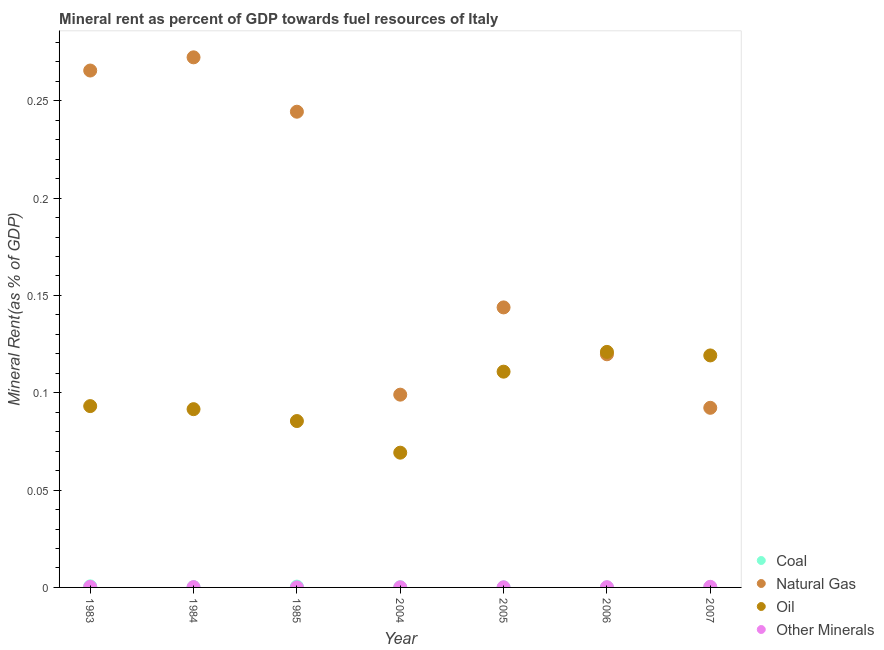Is the number of dotlines equal to the number of legend labels?
Make the answer very short. Yes. What is the natural gas rent in 2004?
Offer a terse response. 0.1. Across all years, what is the maximum natural gas rent?
Your answer should be compact. 0.27. Across all years, what is the minimum  rent of other minerals?
Offer a very short reply. 9.961583224840801e-6. In which year was the  rent of other minerals maximum?
Provide a short and direct response. 2007. What is the total  rent of other minerals in the graph?
Your answer should be very brief. 0. What is the difference between the oil rent in 2004 and that in 2005?
Ensure brevity in your answer.  -0.04. What is the difference between the  rent of other minerals in 1985 and the natural gas rent in 2004?
Offer a terse response. -0.1. What is the average  rent of other minerals per year?
Make the answer very short. 0. In the year 2007, what is the difference between the coal rent and natural gas rent?
Your answer should be compact. -0.09. In how many years, is the natural gas rent greater than 0.24000000000000002 %?
Offer a very short reply. 3. What is the ratio of the natural gas rent in 1985 to that in 2006?
Your response must be concise. 2.04. Is the oil rent in 1984 less than that in 2006?
Your response must be concise. Yes. What is the difference between the highest and the second highest coal rent?
Your response must be concise. 0. What is the difference between the highest and the lowest  rent of other minerals?
Offer a terse response. 0. Is the sum of the natural gas rent in 1983 and 2007 greater than the maximum  rent of other minerals across all years?
Offer a very short reply. Yes. Is it the case that in every year, the sum of the  rent of other minerals and coal rent is greater than the sum of natural gas rent and oil rent?
Your response must be concise. No. Is it the case that in every year, the sum of the coal rent and natural gas rent is greater than the oil rent?
Your answer should be compact. No. Does the oil rent monotonically increase over the years?
Offer a terse response. No. Is the  rent of other minerals strictly less than the natural gas rent over the years?
Your answer should be compact. Yes. How many dotlines are there?
Offer a very short reply. 4. Does the graph contain any zero values?
Make the answer very short. No. Where does the legend appear in the graph?
Your answer should be compact. Bottom right. What is the title of the graph?
Offer a very short reply. Mineral rent as percent of GDP towards fuel resources of Italy. Does "Secondary vocational" appear as one of the legend labels in the graph?
Ensure brevity in your answer.  No. What is the label or title of the Y-axis?
Ensure brevity in your answer.  Mineral Rent(as % of GDP). What is the Mineral Rent(as % of GDP) of Coal in 1983?
Keep it short and to the point. 0. What is the Mineral Rent(as % of GDP) in Natural Gas in 1983?
Keep it short and to the point. 0.27. What is the Mineral Rent(as % of GDP) of Oil in 1983?
Your answer should be very brief. 0.09. What is the Mineral Rent(as % of GDP) of Other Minerals in 1983?
Your response must be concise. 0. What is the Mineral Rent(as % of GDP) of Coal in 1984?
Keep it short and to the point. 0. What is the Mineral Rent(as % of GDP) of Natural Gas in 1984?
Make the answer very short. 0.27. What is the Mineral Rent(as % of GDP) in Oil in 1984?
Provide a succinct answer. 0.09. What is the Mineral Rent(as % of GDP) of Other Minerals in 1984?
Make the answer very short. 0. What is the Mineral Rent(as % of GDP) in Coal in 1985?
Your answer should be compact. 0. What is the Mineral Rent(as % of GDP) of Natural Gas in 1985?
Give a very brief answer. 0.24. What is the Mineral Rent(as % of GDP) in Oil in 1985?
Give a very brief answer. 0.09. What is the Mineral Rent(as % of GDP) of Other Minerals in 1985?
Your response must be concise. 9.961583224840801e-6. What is the Mineral Rent(as % of GDP) in Coal in 2004?
Your answer should be very brief. 6.69671559886923e-5. What is the Mineral Rent(as % of GDP) of Natural Gas in 2004?
Keep it short and to the point. 0.1. What is the Mineral Rent(as % of GDP) of Oil in 2004?
Make the answer very short. 0.07. What is the Mineral Rent(as % of GDP) of Other Minerals in 2004?
Your answer should be very brief. 5.04562722027911e-5. What is the Mineral Rent(as % of GDP) of Coal in 2005?
Offer a very short reply. 1.52938665315344e-5. What is the Mineral Rent(as % of GDP) in Natural Gas in 2005?
Provide a short and direct response. 0.14. What is the Mineral Rent(as % of GDP) in Oil in 2005?
Give a very brief answer. 0.11. What is the Mineral Rent(as % of GDP) in Other Minerals in 2005?
Keep it short and to the point. 5.19978483060913e-5. What is the Mineral Rent(as % of GDP) of Coal in 2006?
Keep it short and to the point. 5.16849671469394e-6. What is the Mineral Rent(as % of GDP) of Natural Gas in 2006?
Provide a succinct answer. 0.12. What is the Mineral Rent(as % of GDP) in Oil in 2006?
Your answer should be compact. 0.12. What is the Mineral Rent(as % of GDP) in Other Minerals in 2006?
Your answer should be very brief. 0. What is the Mineral Rent(as % of GDP) of Coal in 2007?
Your answer should be very brief. 0. What is the Mineral Rent(as % of GDP) in Natural Gas in 2007?
Your response must be concise. 0.09. What is the Mineral Rent(as % of GDP) in Oil in 2007?
Make the answer very short. 0.12. What is the Mineral Rent(as % of GDP) in Other Minerals in 2007?
Keep it short and to the point. 0. Across all years, what is the maximum Mineral Rent(as % of GDP) in Coal?
Your answer should be compact. 0. Across all years, what is the maximum Mineral Rent(as % of GDP) of Natural Gas?
Ensure brevity in your answer.  0.27. Across all years, what is the maximum Mineral Rent(as % of GDP) of Oil?
Provide a short and direct response. 0.12. Across all years, what is the maximum Mineral Rent(as % of GDP) in Other Minerals?
Offer a very short reply. 0. Across all years, what is the minimum Mineral Rent(as % of GDP) in Coal?
Give a very brief answer. 5.16849671469394e-6. Across all years, what is the minimum Mineral Rent(as % of GDP) in Natural Gas?
Offer a terse response. 0.09. Across all years, what is the minimum Mineral Rent(as % of GDP) of Oil?
Make the answer very short. 0.07. Across all years, what is the minimum Mineral Rent(as % of GDP) in Other Minerals?
Keep it short and to the point. 9.961583224840801e-6. What is the total Mineral Rent(as % of GDP) in Coal in the graph?
Make the answer very short. 0. What is the total Mineral Rent(as % of GDP) of Natural Gas in the graph?
Your response must be concise. 1.24. What is the total Mineral Rent(as % of GDP) of Oil in the graph?
Give a very brief answer. 0.69. What is the difference between the Mineral Rent(as % of GDP) of Coal in 1983 and that in 1984?
Make the answer very short. 0. What is the difference between the Mineral Rent(as % of GDP) of Natural Gas in 1983 and that in 1984?
Ensure brevity in your answer.  -0.01. What is the difference between the Mineral Rent(as % of GDP) of Oil in 1983 and that in 1984?
Ensure brevity in your answer.  0. What is the difference between the Mineral Rent(as % of GDP) in Coal in 1983 and that in 1985?
Keep it short and to the point. 0. What is the difference between the Mineral Rent(as % of GDP) in Natural Gas in 1983 and that in 1985?
Offer a terse response. 0.02. What is the difference between the Mineral Rent(as % of GDP) in Oil in 1983 and that in 1985?
Give a very brief answer. 0.01. What is the difference between the Mineral Rent(as % of GDP) in Natural Gas in 1983 and that in 2004?
Offer a very short reply. 0.17. What is the difference between the Mineral Rent(as % of GDP) of Oil in 1983 and that in 2004?
Make the answer very short. 0.02. What is the difference between the Mineral Rent(as % of GDP) of Coal in 1983 and that in 2005?
Offer a very short reply. 0. What is the difference between the Mineral Rent(as % of GDP) in Natural Gas in 1983 and that in 2005?
Give a very brief answer. 0.12. What is the difference between the Mineral Rent(as % of GDP) of Oil in 1983 and that in 2005?
Your response must be concise. -0.02. What is the difference between the Mineral Rent(as % of GDP) of Other Minerals in 1983 and that in 2005?
Ensure brevity in your answer.  0. What is the difference between the Mineral Rent(as % of GDP) of Natural Gas in 1983 and that in 2006?
Keep it short and to the point. 0.15. What is the difference between the Mineral Rent(as % of GDP) of Oil in 1983 and that in 2006?
Offer a very short reply. -0.03. What is the difference between the Mineral Rent(as % of GDP) in Coal in 1983 and that in 2007?
Your response must be concise. 0. What is the difference between the Mineral Rent(as % of GDP) in Natural Gas in 1983 and that in 2007?
Make the answer very short. 0.17. What is the difference between the Mineral Rent(as % of GDP) in Oil in 1983 and that in 2007?
Make the answer very short. -0.03. What is the difference between the Mineral Rent(as % of GDP) of Coal in 1984 and that in 1985?
Make the answer very short. -0. What is the difference between the Mineral Rent(as % of GDP) in Natural Gas in 1984 and that in 1985?
Make the answer very short. 0.03. What is the difference between the Mineral Rent(as % of GDP) in Oil in 1984 and that in 1985?
Ensure brevity in your answer.  0.01. What is the difference between the Mineral Rent(as % of GDP) of Other Minerals in 1984 and that in 1985?
Offer a very short reply. 0. What is the difference between the Mineral Rent(as % of GDP) in Coal in 1984 and that in 2004?
Ensure brevity in your answer.  0. What is the difference between the Mineral Rent(as % of GDP) in Natural Gas in 1984 and that in 2004?
Your answer should be compact. 0.17. What is the difference between the Mineral Rent(as % of GDP) of Oil in 1984 and that in 2004?
Keep it short and to the point. 0.02. What is the difference between the Mineral Rent(as % of GDP) of Coal in 1984 and that in 2005?
Offer a very short reply. 0. What is the difference between the Mineral Rent(as % of GDP) in Natural Gas in 1984 and that in 2005?
Provide a short and direct response. 0.13. What is the difference between the Mineral Rent(as % of GDP) of Oil in 1984 and that in 2005?
Make the answer very short. -0.02. What is the difference between the Mineral Rent(as % of GDP) in Coal in 1984 and that in 2006?
Offer a very short reply. 0. What is the difference between the Mineral Rent(as % of GDP) in Natural Gas in 1984 and that in 2006?
Your response must be concise. 0.15. What is the difference between the Mineral Rent(as % of GDP) of Oil in 1984 and that in 2006?
Your answer should be compact. -0.03. What is the difference between the Mineral Rent(as % of GDP) in Natural Gas in 1984 and that in 2007?
Your answer should be compact. 0.18. What is the difference between the Mineral Rent(as % of GDP) of Oil in 1984 and that in 2007?
Provide a succinct answer. -0.03. What is the difference between the Mineral Rent(as % of GDP) in Other Minerals in 1984 and that in 2007?
Give a very brief answer. -0. What is the difference between the Mineral Rent(as % of GDP) of Coal in 1985 and that in 2004?
Offer a very short reply. 0. What is the difference between the Mineral Rent(as % of GDP) in Natural Gas in 1985 and that in 2004?
Provide a short and direct response. 0.15. What is the difference between the Mineral Rent(as % of GDP) in Oil in 1985 and that in 2004?
Your response must be concise. 0.02. What is the difference between the Mineral Rent(as % of GDP) of Other Minerals in 1985 and that in 2004?
Make the answer very short. -0. What is the difference between the Mineral Rent(as % of GDP) of Natural Gas in 1985 and that in 2005?
Offer a terse response. 0.1. What is the difference between the Mineral Rent(as % of GDP) of Oil in 1985 and that in 2005?
Offer a very short reply. -0.03. What is the difference between the Mineral Rent(as % of GDP) of Natural Gas in 1985 and that in 2006?
Offer a very short reply. 0.12. What is the difference between the Mineral Rent(as % of GDP) of Oil in 1985 and that in 2006?
Keep it short and to the point. -0.04. What is the difference between the Mineral Rent(as % of GDP) of Other Minerals in 1985 and that in 2006?
Offer a very short reply. -0. What is the difference between the Mineral Rent(as % of GDP) in Natural Gas in 1985 and that in 2007?
Your answer should be compact. 0.15. What is the difference between the Mineral Rent(as % of GDP) of Oil in 1985 and that in 2007?
Your answer should be compact. -0.03. What is the difference between the Mineral Rent(as % of GDP) of Other Minerals in 1985 and that in 2007?
Offer a very short reply. -0. What is the difference between the Mineral Rent(as % of GDP) in Coal in 2004 and that in 2005?
Your answer should be compact. 0. What is the difference between the Mineral Rent(as % of GDP) in Natural Gas in 2004 and that in 2005?
Offer a very short reply. -0.04. What is the difference between the Mineral Rent(as % of GDP) of Oil in 2004 and that in 2005?
Provide a succinct answer. -0.04. What is the difference between the Mineral Rent(as % of GDP) in Coal in 2004 and that in 2006?
Offer a very short reply. 0. What is the difference between the Mineral Rent(as % of GDP) of Natural Gas in 2004 and that in 2006?
Keep it short and to the point. -0.02. What is the difference between the Mineral Rent(as % of GDP) of Oil in 2004 and that in 2006?
Your answer should be very brief. -0.05. What is the difference between the Mineral Rent(as % of GDP) in Other Minerals in 2004 and that in 2006?
Your answer should be compact. -0. What is the difference between the Mineral Rent(as % of GDP) of Natural Gas in 2004 and that in 2007?
Give a very brief answer. 0.01. What is the difference between the Mineral Rent(as % of GDP) of Other Minerals in 2004 and that in 2007?
Ensure brevity in your answer.  -0. What is the difference between the Mineral Rent(as % of GDP) in Coal in 2005 and that in 2006?
Make the answer very short. 0. What is the difference between the Mineral Rent(as % of GDP) in Natural Gas in 2005 and that in 2006?
Provide a short and direct response. 0.02. What is the difference between the Mineral Rent(as % of GDP) in Oil in 2005 and that in 2006?
Give a very brief answer. -0.01. What is the difference between the Mineral Rent(as % of GDP) in Other Minerals in 2005 and that in 2006?
Make the answer very short. -0. What is the difference between the Mineral Rent(as % of GDP) in Coal in 2005 and that in 2007?
Provide a short and direct response. -0. What is the difference between the Mineral Rent(as % of GDP) of Natural Gas in 2005 and that in 2007?
Your answer should be very brief. 0.05. What is the difference between the Mineral Rent(as % of GDP) in Oil in 2005 and that in 2007?
Provide a succinct answer. -0.01. What is the difference between the Mineral Rent(as % of GDP) of Other Minerals in 2005 and that in 2007?
Provide a short and direct response. -0. What is the difference between the Mineral Rent(as % of GDP) in Coal in 2006 and that in 2007?
Provide a succinct answer. -0. What is the difference between the Mineral Rent(as % of GDP) in Natural Gas in 2006 and that in 2007?
Keep it short and to the point. 0.03. What is the difference between the Mineral Rent(as % of GDP) of Oil in 2006 and that in 2007?
Offer a terse response. 0. What is the difference between the Mineral Rent(as % of GDP) in Other Minerals in 2006 and that in 2007?
Ensure brevity in your answer.  -0. What is the difference between the Mineral Rent(as % of GDP) in Coal in 1983 and the Mineral Rent(as % of GDP) in Natural Gas in 1984?
Make the answer very short. -0.27. What is the difference between the Mineral Rent(as % of GDP) in Coal in 1983 and the Mineral Rent(as % of GDP) in Oil in 1984?
Offer a terse response. -0.09. What is the difference between the Mineral Rent(as % of GDP) of Natural Gas in 1983 and the Mineral Rent(as % of GDP) of Oil in 1984?
Make the answer very short. 0.17. What is the difference between the Mineral Rent(as % of GDP) in Natural Gas in 1983 and the Mineral Rent(as % of GDP) in Other Minerals in 1984?
Keep it short and to the point. 0.27. What is the difference between the Mineral Rent(as % of GDP) of Oil in 1983 and the Mineral Rent(as % of GDP) of Other Minerals in 1984?
Your answer should be very brief. 0.09. What is the difference between the Mineral Rent(as % of GDP) of Coal in 1983 and the Mineral Rent(as % of GDP) of Natural Gas in 1985?
Your response must be concise. -0.24. What is the difference between the Mineral Rent(as % of GDP) of Coal in 1983 and the Mineral Rent(as % of GDP) of Oil in 1985?
Provide a succinct answer. -0.08. What is the difference between the Mineral Rent(as % of GDP) of Natural Gas in 1983 and the Mineral Rent(as % of GDP) of Oil in 1985?
Keep it short and to the point. 0.18. What is the difference between the Mineral Rent(as % of GDP) in Natural Gas in 1983 and the Mineral Rent(as % of GDP) in Other Minerals in 1985?
Provide a short and direct response. 0.27. What is the difference between the Mineral Rent(as % of GDP) of Oil in 1983 and the Mineral Rent(as % of GDP) of Other Minerals in 1985?
Your answer should be compact. 0.09. What is the difference between the Mineral Rent(as % of GDP) of Coal in 1983 and the Mineral Rent(as % of GDP) of Natural Gas in 2004?
Your answer should be very brief. -0.1. What is the difference between the Mineral Rent(as % of GDP) of Coal in 1983 and the Mineral Rent(as % of GDP) of Oil in 2004?
Make the answer very short. -0.07. What is the difference between the Mineral Rent(as % of GDP) of Coal in 1983 and the Mineral Rent(as % of GDP) of Other Minerals in 2004?
Give a very brief answer. 0. What is the difference between the Mineral Rent(as % of GDP) in Natural Gas in 1983 and the Mineral Rent(as % of GDP) in Oil in 2004?
Offer a terse response. 0.2. What is the difference between the Mineral Rent(as % of GDP) of Natural Gas in 1983 and the Mineral Rent(as % of GDP) of Other Minerals in 2004?
Keep it short and to the point. 0.27. What is the difference between the Mineral Rent(as % of GDP) in Oil in 1983 and the Mineral Rent(as % of GDP) in Other Minerals in 2004?
Your answer should be compact. 0.09. What is the difference between the Mineral Rent(as % of GDP) of Coal in 1983 and the Mineral Rent(as % of GDP) of Natural Gas in 2005?
Ensure brevity in your answer.  -0.14. What is the difference between the Mineral Rent(as % of GDP) in Coal in 1983 and the Mineral Rent(as % of GDP) in Oil in 2005?
Give a very brief answer. -0.11. What is the difference between the Mineral Rent(as % of GDP) of Coal in 1983 and the Mineral Rent(as % of GDP) of Other Minerals in 2005?
Ensure brevity in your answer.  0. What is the difference between the Mineral Rent(as % of GDP) of Natural Gas in 1983 and the Mineral Rent(as % of GDP) of Oil in 2005?
Offer a terse response. 0.15. What is the difference between the Mineral Rent(as % of GDP) in Natural Gas in 1983 and the Mineral Rent(as % of GDP) in Other Minerals in 2005?
Your answer should be compact. 0.27. What is the difference between the Mineral Rent(as % of GDP) of Oil in 1983 and the Mineral Rent(as % of GDP) of Other Minerals in 2005?
Your answer should be very brief. 0.09. What is the difference between the Mineral Rent(as % of GDP) in Coal in 1983 and the Mineral Rent(as % of GDP) in Natural Gas in 2006?
Your response must be concise. -0.12. What is the difference between the Mineral Rent(as % of GDP) in Coal in 1983 and the Mineral Rent(as % of GDP) in Oil in 2006?
Offer a very short reply. -0.12. What is the difference between the Mineral Rent(as % of GDP) in Coal in 1983 and the Mineral Rent(as % of GDP) in Other Minerals in 2006?
Offer a very short reply. 0. What is the difference between the Mineral Rent(as % of GDP) of Natural Gas in 1983 and the Mineral Rent(as % of GDP) of Oil in 2006?
Ensure brevity in your answer.  0.14. What is the difference between the Mineral Rent(as % of GDP) in Natural Gas in 1983 and the Mineral Rent(as % of GDP) in Other Minerals in 2006?
Ensure brevity in your answer.  0.27. What is the difference between the Mineral Rent(as % of GDP) in Oil in 1983 and the Mineral Rent(as % of GDP) in Other Minerals in 2006?
Ensure brevity in your answer.  0.09. What is the difference between the Mineral Rent(as % of GDP) of Coal in 1983 and the Mineral Rent(as % of GDP) of Natural Gas in 2007?
Ensure brevity in your answer.  -0.09. What is the difference between the Mineral Rent(as % of GDP) in Coal in 1983 and the Mineral Rent(as % of GDP) in Oil in 2007?
Your answer should be compact. -0.12. What is the difference between the Mineral Rent(as % of GDP) in Natural Gas in 1983 and the Mineral Rent(as % of GDP) in Oil in 2007?
Your answer should be very brief. 0.15. What is the difference between the Mineral Rent(as % of GDP) in Natural Gas in 1983 and the Mineral Rent(as % of GDP) in Other Minerals in 2007?
Provide a short and direct response. 0.27. What is the difference between the Mineral Rent(as % of GDP) of Oil in 1983 and the Mineral Rent(as % of GDP) of Other Minerals in 2007?
Your response must be concise. 0.09. What is the difference between the Mineral Rent(as % of GDP) in Coal in 1984 and the Mineral Rent(as % of GDP) in Natural Gas in 1985?
Keep it short and to the point. -0.24. What is the difference between the Mineral Rent(as % of GDP) of Coal in 1984 and the Mineral Rent(as % of GDP) of Oil in 1985?
Ensure brevity in your answer.  -0.09. What is the difference between the Mineral Rent(as % of GDP) of Coal in 1984 and the Mineral Rent(as % of GDP) of Other Minerals in 1985?
Your answer should be compact. 0. What is the difference between the Mineral Rent(as % of GDP) in Natural Gas in 1984 and the Mineral Rent(as % of GDP) in Oil in 1985?
Provide a succinct answer. 0.19. What is the difference between the Mineral Rent(as % of GDP) of Natural Gas in 1984 and the Mineral Rent(as % of GDP) of Other Minerals in 1985?
Your answer should be compact. 0.27. What is the difference between the Mineral Rent(as % of GDP) in Oil in 1984 and the Mineral Rent(as % of GDP) in Other Minerals in 1985?
Offer a very short reply. 0.09. What is the difference between the Mineral Rent(as % of GDP) in Coal in 1984 and the Mineral Rent(as % of GDP) in Natural Gas in 2004?
Provide a succinct answer. -0.1. What is the difference between the Mineral Rent(as % of GDP) in Coal in 1984 and the Mineral Rent(as % of GDP) in Oil in 2004?
Offer a terse response. -0.07. What is the difference between the Mineral Rent(as % of GDP) in Coal in 1984 and the Mineral Rent(as % of GDP) in Other Minerals in 2004?
Ensure brevity in your answer.  0. What is the difference between the Mineral Rent(as % of GDP) in Natural Gas in 1984 and the Mineral Rent(as % of GDP) in Oil in 2004?
Keep it short and to the point. 0.2. What is the difference between the Mineral Rent(as % of GDP) in Natural Gas in 1984 and the Mineral Rent(as % of GDP) in Other Minerals in 2004?
Offer a terse response. 0.27. What is the difference between the Mineral Rent(as % of GDP) of Oil in 1984 and the Mineral Rent(as % of GDP) of Other Minerals in 2004?
Provide a short and direct response. 0.09. What is the difference between the Mineral Rent(as % of GDP) in Coal in 1984 and the Mineral Rent(as % of GDP) in Natural Gas in 2005?
Your answer should be compact. -0.14. What is the difference between the Mineral Rent(as % of GDP) in Coal in 1984 and the Mineral Rent(as % of GDP) in Oil in 2005?
Offer a terse response. -0.11. What is the difference between the Mineral Rent(as % of GDP) of Natural Gas in 1984 and the Mineral Rent(as % of GDP) of Oil in 2005?
Your answer should be very brief. 0.16. What is the difference between the Mineral Rent(as % of GDP) of Natural Gas in 1984 and the Mineral Rent(as % of GDP) of Other Minerals in 2005?
Offer a terse response. 0.27. What is the difference between the Mineral Rent(as % of GDP) of Oil in 1984 and the Mineral Rent(as % of GDP) of Other Minerals in 2005?
Make the answer very short. 0.09. What is the difference between the Mineral Rent(as % of GDP) of Coal in 1984 and the Mineral Rent(as % of GDP) of Natural Gas in 2006?
Your answer should be very brief. -0.12. What is the difference between the Mineral Rent(as % of GDP) in Coal in 1984 and the Mineral Rent(as % of GDP) in Oil in 2006?
Your answer should be compact. -0.12. What is the difference between the Mineral Rent(as % of GDP) of Coal in 1984 and the Mineral Rent(as % of GDP) of Other Minerals in 2006?
Provide a succinct answer. -0. What is the difference between the Mineral Rent(as % of GDP) of Natural Gas in 1984 and the Mineral Rent(as % of GDP) of Oil in 2006?
Keep it short and to the point. 0.15. What is the difference between the Mineral Rent(as % of GDP) in Natural Gas in 1984 and the Mineral Rent(as % of GDP) in Other Minerals in 2006?
Offer a very short reply. 0.27. What is the difference between the Mineral Rent(as % of GDP) of Oil in 1984 and the Mineral Rent(as % of GDP) of Other Minerals in 2006?
Provide a succinct answer. 0.09. What is the difference between the Mineral Rent(as % of GDP) of Coal in 1984 and the Mineral Rent(as % of GDP) of Natural Gas in 2007?
Keep it short and to the point. -0.09. What is the difference between the Mineral Rent(as % of GDP) of Coal in 1984 and the Mineral Rent(as % of GDP) of Oil in 2007?
Provide a succinct answer. -0.12. What is the difference between the Mineral Rent(as % of GDP) of Coal in 1984 and the Mineral Rent(as % of GDP) of Other Minerals in 2007?
Your response must be concise. -0. What is the difference between the Mineral Rent(as % of GDP) of Natural Gas in 1984 and the Mineral Rent(as % of GDP) of Oil in 2007?
Offer a terse response. 0.15. What is the difference between the Mineral Rent(as % of GDP) in Natural Gas in 1984 and the Mineral Rent(as % of GDP) in Other Minerals in 2007?
Your answer should be compact. 0.27. What is the difference between the Mineral Rent(as % of GDP) of Oil in 1984 and the Mineral Rent(as % of GDP) of Other Minerals in 2007?
Keep it short and to the point. 0.09. What is the difference between the Mineral Rent(as % of GDP) in Coal in 1985 and the Mineral Rent(as % of GDP) in Natural Gas in 2004?
Your answer should be very brief. -0.1. What is the difference between the Mineral Rent(as % of GDP) in Coal in 1985 and the Mineral Rent(as % of GDP) in Oil in 2004?
Make the answer very short. -0.07. What is the difference between the Mineral Rent(as % of GDP) in Natural Gas in 1985 and the Mineral Rent(as % of GDP) in Oil in 2004?
Give a very brief answer. 0.18. What is the difference between the Mineral Rent(as % of GDP) in Natural Gas in 1985 and the Mineral Rent(as % of GDP) in Other Minerals in 2004?
Provide a succinct answer. 0.24. What is the difference between the Mineral Rent(as % of GDP) of Oil in 1985 and the Mineral Rent(as % of GDP) of Other Minerals in 2004?
Offer a terse response. 0.09. What is the difference between the Mineral Rent(as % of GDP) in Coal in 1985 and the Mineral Rent(as % of GDP) in Natural Gas in 2005?
Provide a short and direct response. -0.14. What is the difference between the Mineral Rent(as % of GDP) in Coal in 1985 and the Mineral Rent(as % of GDP) in Oil in 2005?
Make the answer very short. -0.11. What is the difference between the Mineral Rent(as % of GDP) of Natural Gas in 1985 and the Mineral Rent(as % of GDP) of Oil in 2005?
Ensure brevity in your answer.  0.13. What is the difference between the Mineral Rent(as % of GDP) in Natural Gas in 1985 and the Mineral Rent(as % of GDP) in Other Minerals in 2005?
Offer a very short reply. 0.24. What is the difference between the Mineral Rent(as % of GDP) in Oil in 1985 and the Mineral Rent(as % of GDP) in Other Minerals in 2005?
Your answer should be very brief. 0.09. What is the difference between the Mineral Rent(as % of GDP) of Coal in 1985 and the Mineral Rent(as % of GDP) of Natural Gas in 2006?
Ensure brevity in your answer.  -0.12. What is the difference between the Mineral Rent(as % of GDP) of Coal in 1985 and the Mineral Rent(as % of GDP) of Oil in 2006?
Offer a very short reply. -0.12. What is the difference between the Mineral Rent(as % of GDP) in Coal in 1985 and the Mineral Rent(as % of GDP) in Other Minerals in 2006?
Make the answer very short. 0. What is the difference between the Mineral Rent(as % of GDP) of Natural Gas in 1985 and the Mineral Rent(as % of GDP) of Oil in 2006?
Your response must be concise. 0.12. What is the difference between the Mineral Rent(as % of GDP) in Natural Gas in 1985 and the Mineral Rent(as % of GDP) in Other Minerals in 2006?
Your response must be concise. 0.24. What is the difference between the Mineral Rent(as % of GDP) of Oil in 1985 and the Mineral Rent(as % of GDP) of Other Minerals in 2006?
Give a very brief answer. 0.09. What is the difference between the Mineral Rent(as % of GDP) of Coal in 1985 and the Mineral Rent(as % of GDP) of Natural Gas in 2007?
Give a very brief answer. -0.09. What is the difference between the Mineral Rent(as % of GDP) in Coal in 1985 and the Mineral Rent(as % of GDP) in Oil in 2007?
Offer a terse response. -0.12. What is the difference between the Mineral Rent(as % of GDP) in Natural Gas in 1985 and the Mineral Rent(as % of GDP) in Oil in 2007?
Ensure brevity in your answer.  0.13. What is the difference between the Mineral Rent(as % of GDP) of Natural Gas in 1985 and the Mineral Rent(as % of GDP) of Other Minerals in 2007?
Offer a terse response. 0.24. What is the difference between the Mineral Rent(as % of GDP) in Oil in 1985 and the Mineral Rent(as % of GDP) in Other Minerals in 2007?
Offer a terse response. 0.09. What is the difference between the Mineral Rent(as % of GDP) of Coal in 2004 and the Mineral Rent(as % of GDP) of Natural Gas in 2005?
Keep it short and to the point. -0.14. What is the difference between the Mineral Rent(as % of GDP) of Coal in 2004 and the Mineral Rent(as % of GDP) of Oil in 2005?
Ensure brevity in your answer.  -0.11. What is the difference between the Mineral Rent(as % of GDP) of Coal in 2004 and the Mineral Rent(as % of GDP) of Other Minerals in 2005?
Provide a succinct answer. 0. What is the difference between the Mineral Rent(as % of GDP) in Natural Gas in 2004 and the Mineral Rent(as % of GDP) in Oil in 2005?
Your response must be concise. -0.01. What is the difference between the Mineral Rent(as % of GDP) of Natural Gas in 2004 and the Mineral Rent(as % of GDP) of Other Minerals in 2005?
Keep it short and to the point. 0.1. What is the difference between the Mineral Rent(as % of GDP) in Oil in 2004 and the Mineral Rent(as % of GDP) in Other Minerals in 2005?
Offer a terse response. 0.07. What is the difference between the Mineral Rent(as % of GDP) of Coal in 2004 and the Mineral Rent(as % of GDP) of Natural Gas in 2006?
Provide a succinct answer. -0.12. What is the difference between the Mineral Rent(as % of GDP) in Coal in 2004 and the Mineral Rent(as % of GDP) in Oil in 2006?
Keep it short and to the point. -0.12. What is the difference between the Mineral Rent(as % of GDP) in Coal in 2004 and the Mineral Rent(as % of GDP) in Other Minerals in 2006?
Your answer should be very brief. -0. What is the difference between the Mineral Rent(as % of GDP) in Natural Gas in 2004 and the Mineral Rent(as % of GDP) in Oil in 2006?
Ensure brevity in your answer.  -0.02. What is the difference between the Mineral Rent(as % of GDP) of Natural Gas in 2004 and the Mineral Rent(as % of GDP) of Other Minerals in 2006?
Give a very brief answer. 0.1. What is the difference between the Mineral Rent(as % of GDP) in Oil in 2004 and the Mineral Rent(as % of GDP) in Other Minerals in 2006?
Provide a succinct answer. 0.07. What is the difference between the Mineral Rent(as % of GDP) of Coal in 2004 and the Mineral Rent(as % of GDP) of Natural Gas in 2007?
Offer a very short reply. -0.09. What is the difference between the Mineral Rent(as % of GDP) of Coal in 2004 and the Mineral Rent(as % of GDP) of Oil in 2007?
Your response must be concise. -0.12. What is the difference between the Mineral Rent(as % of GDP) of Coal in 2004 and the Mineral Rent(as % of GDP) of Other Minerals in 2007?
Give a very brief answer. -0. What is the difference between the Mineral Rent(as % of GDP) of Natural Gas in 2004 and the Mineral Rent(as % of GDP) of Oil in 2007?
Your answer should be compact. -0.02. What is the difference between the Mineral Rent(as % of GDP) of Natural Gas in 2004 and the Mineral Rent(as % of GDP) of Other Minerals in 2007?
Ensure brevity in your answer.  0.1. What is the difference between the Mineral Rent(as % of GDP) of Oil in 2004 and the Mineral Rent(as % of GDP) of Other Minerals in 2007?
Provide a short and direct response. 0.07. What is the difference between the Mineral Rent(as % of GDP) of Coal in 2005 and the Mineral Rent(as % of GDP) of Natural Gas in 2006?
Give a very brief answer. -0.12. What is the difference between the Mineral Rent(as % of GDP) of Coal in 2005 and the Mineral Rent(as % of GDP) of Oil in 2006?
Give a very brief answer. -0.12. What is the difference between the Mineral Rent(as % of GDP) in Coal in 2005 and the Mineral Rent(as % of GDP) in Other Minerals in 2006?
Keep it short and to the point. -0. What is the difference between the Mineral Rent(as % of GDP) in Natural Gas in 2005 and the Mineral Rent(as % of GDP) in Oil in 2006?
Ensure brevity in your answer.  0.02. What is the difference between the Mineral Rent(as % of GDP) of Natural Gas in 2005 and the Mineral Rent(as % of GDP) of Other Minerals in 2006?
Keep it short and to the point. 0.14. What is the difference between the Mineral Rent(as % of GDP) of Oil in 2005 and the Mineral Rent(as % of GDP) of Other Minerals in 2006?
Provide a succinct answer. 0.11. What is the difference between the Mineral Rent(as % of GDP) in Coal in 2005 and the Mineral Rent(as % of GDP) in Natural Gas in 2007?
Your answer should be compact. -0.09. What is the difference between the Mineral Rent(as % of GDP) in Coal in 2005 and the Mineral Rent(as % of GDP) in Oil in 2007?
Provide a short and direct response. -0.12. What is the difference between the Mineral Rent(as % of GDP) in Coal in 2005 and the Mineral Rent(as % of GDP) in Other Minerals in 2007?
Provide a succinct answer. -0. What is the difference between the Mineral Rent(as % of GDP) of Natural Gas in 2005 and the Mineral Rent(as % of GDP) of Oil in 2007?
Provide a short and direct response. 0.02. What is the difference between the Mineral Rent(as % of GDP) of Natural Gas in 2005 and the Mineral Rent(as % of GDP) of Other Minerals in 2007?
Your response must be concise. 0.14. What is the difference between the Mineral Rent(as % of GDP) of Oil in 2005 and the Mineral Rent(as % of GDP) of Other Minerals in 2007?
Offer a very short reply. 0.11. What is the difference between the Mineral Rent(as % of GDP) of Coal in 2006 and the Mineral Rent(as % of GDP) of Natural Gas in 2007?
Your answer should be very brief. -0.09. What is the difference between the Mineral Rent(as % of GDP) of Coal in 2006 and the Mineral Rent(as % of GDP) of Oil in 2007?
Offer a terse response. -0.12. What is the difference between the Mineral Rent(as % of GDP) of Coal in 2006 and the Mineral Rent(as % of GDP) of Other Minerals in 2007?
Make the answer very short. -0. What is the difference between the Mineral Rent(as % of GDP) in Natural Gas in 2006 and the Mineral Rent(as % of GDP) in Oil in 2007?
Offer a terse response. 0. What is the difference between the Mineral Rent(as % of GDP) of Natural Gas in 2006 and the Mineral Rent(as % of GDP) of Other Minerals in 2007?
Provide a short and direct response. 0.12. What is the difference between the Mineral Rent(as % of GDP) in Oil in 2006 and the Mineral Rent(as % of GDP) in Other Minerals in 2007?
Your answer should be very brief. 0.12. What is the average Mineral Rent(as % of GDP) in Coal per year?
Make the answer very short. 0. What is the average Mineral Rent(as % of GDP) of Natural Gas per year?
Ensure brevity in your answer.  0.18. What is the average Mineral Rent(as % of GDP) in Oil per year?
Provide a succinct answer. 0.1. In the year 1983, what is the difference between the Mineral Rent(as % of GDP) in Coal and Mineral Rent(as % of GDP) in Natural Gas?
Offer a very short reply. -0.27. In the year 1983, what is the difference between the Mineral Rent(as % of GDP) of Coal and Mineral Rent(as % of GDP) of Oil?
Offer a terse response. -0.09. In the year 1983, what is the difference between the Mineral Rent(as % of GDP) of Coal and Mineral Rent(as % of GDP) of Other Minerals?
Give a very brief answer. 0. In the year 1983, what is the difference between the Mineral Rent(as % of GDP) of Natural Gas and Mineral Rent(as % of GDP) of Oil?
Give a very brief answer. 0.17. In the year 1983, what is the difference between the Mineral Rent(as % of GDP) of Natural Gas and Mineral Rent(as % of GDP) of Other Minerals?
Your answer should be very brief. 0.27. In the year 1983, what is the difference between the Mineral Rent(as % of GDP) of Oil and Mineral Rent(as % of GDP) of Other Minerals?
Keep it short and to the point. 0.09. In the year 1984, what is the difference between the Mineral Rent(as % of GDP) in Coal and Mineral Rent(as % of GDP) in Natural Gas?
Offer a very short reply. -0.27. In the year 1984, what is the difference between the Mineral Rent(as % of GDP) in Coal and Mineral Rent(as % of GDP) in Oil?
Keep it short and to the point. -0.09. In the year 1984, what is the difference between the Mineral Rent(as % of GDP) of Natural Gas and Mineral Rent(as % of GDP) of Oil?
Your answer should be very brief. 0.18. In the year 1984, what is the difference between the Mineral Rent(as % of GDP) in Natural Gas and Mineral Rent(as % of GDP) in Other Minerals?
Provide a short and direct response. 0.27. In the year 1984, what is the difference between the Mineral Rent(as % of GDP) in Oil and Mineral Rent(as % of GDP) in Other Minerals?
Keep it short and to the point. 0.09. In the year 1985, what is the difference between the Mineral Rent(as % of GDP) of Coal and Mineral Rent(as % of GDP) of Natural Gas?
Keep it short and to the point. -0.24. In the year 1985, what is the difference between the Mineral Rent(as % of GDP) of Coal and Mineral Rent(as % of GDP) of Oil?
Give a very brief answer. -0.09. In the year 1985, what is the difference between the Mineral Rent(as % of GDP) of Natural Gas and Mineral Rent(as % of GDP) of Oil?
Give a very brief answer. 0.16. In the year 1985, what is the difference between the Mineral Rent(as % of GDP) in Natural Gas and Mineral Rent(as % of GDP) in Other Minerals?
Provide a succinct answer. 0.24. In the year 1985, what is the difference between the Mineral Rent(as % of GDP) of Oil and Mineral Rent(as % of GDP) of Other Minerals?
Your response must be concise. 0.09. In the year 2004, what is the difference between the Mineral Rent(as % of GDP) of Coal and Mineral Rent(as % of GDP) of Natural Gas?
Ensure brevity in your answer.  -0.1. In the year 2004, what is the difference between the Mineral Rent(as % of GDP) of Coal and Mineral Rent(as % of GDP) of Oil?
Provide a succinct answer. -0.07. In the year 2004, what is the difference between the Mineral Rent(as % of GDP) of Natural Gas and Mineral Rent(as % of GDP) of Oil?
Your response must be concise. 0.03. In the year 2004, what is the difference between the Mineral Rent(as % of GDP) of Natural Gas and Mineral Rent(as % of GDP) of Other Minerals?
Provide a succinct answer. 0.1. In the year 2004, what is the difference between the Mineral Rent(as % of GDP) in Oil and Mineral Rent(as % of GDP) in Other Minerals?
Ensure brevity in your answer.  0.07. In the year 2005, what is the difference between the Mineral Rent(as % of GDP) of Coal and Mineral Rent(as % of GDP) of Natural Gas?
Offer a very short reply. -0.14. In the year 2005, what is the difference between the Mineral Rent(as % of GDP) of Coal and Mineral Rent(as % of GDP) of Oil?
Make the answer very short. -0.11. In the year 2005, what is the difference between the Mineral Rent(as % of GDP) in Natural Gas and Mineral Rent(as % of GDP) in Oil?
Ensure brevity in your answer.  0.03. In the year 2005, what is the difference between the Mineral Rent(as % of GDP) of Natural Gas and Mineral Rent(as % of GDP) of Other Minerals?
Offer a very short reply. 0.14. In the year 2005, what is the difference between the Mineral Rent(as % of GDP) of Oil and Mineral Rent(as % of GDP) of Other Minerals?
Your answer should be compact. 0.11. In the year 2006, what is the difference between the Mineral Rent(as % of GDP) in Coal and Mineral Rent(as % of GDP) in Natural Gas?
Your answer should be compact. -0.12. In the year 2006, what is the difference between the Mineral Rent(as % of GDP) of Coal and Mineral Rent(as % of GDP) of Oil?
Provide a succinct answer. -0.12. In the year 2006, what is the difference between the Mineral Rent(as % of GDP) of Coal and Mineral Rent(as % of GDP) of Other Minerals?
Offer a very short reply. -0. In the year 2006, what is the difference between the Mineral Rent(as % of GDP) in Natural Gas and Mineral Rent(as % of GDP) in Oil?
Your response must be concise. -0. In the year 2006, what is the difference between the Mineral Rent(as % of GDP) in Natural Gas and Mineral Rent(as % of GDP) in Other Minerals?
Offer a terse response. 0.12. In the year 2006, what is the difference between the Mineral Rent(as % of GDP) of Oil and Mineral Rent(as % of GDP) of Other Minerals?
Keep it short and to the point. 0.12. In the year 2007, what is the difference between the Mineral Rent(as % of GDP) of Coal and Mineral Rent(as % of GDP) of Natural Gas?
Provide a short and direct response. -0.09. In the year 2007, what is the difference between the Mineral Rent(as % of GDP) in Coal and Mineral Rent(as % of GDP) in Oil?
Your answer should be compact. -0.12. In the year 2007, what is the difference between the Mineral Rent(as % of GDP) of Coal and Mineral Rent(as % of GDP) of Other Minerals?
Your answer should be very brief. -0. In the year 2007, what is the difference between the Mineral Rent(as % of GDP) in Natural Gas and Mineral Rent(as % of GDP) in Oil?
Your response must be concise. -0.03. In the year 2007, what is the difference between the Mineral Rent(as % of GDP) in Natural Gas and Mineral Rent(as % of GDP) in Other Minerals?
Give a very brief answer. 0.09. In the year 2007, what is the difference between the Mineral Rent(as % of GDP) of Oil and Mineral Rent(as % of GDP) of Other Minerals?
Offer a very short reply. 0.12. What is the ratio of the Mineral Rent(as % of GDP) in Coal in 1983 to that in 1984?
Your answer should be very brief. 4.41. What is the ratio of the Mineral Rent(as % of GDP) in Natural Gas in 1983 to that in 1984?
Provide a succinct answer. 0.98. What is the ratio of the Mineral Rent(as % of GDP) of Oil in 1983 to that in 1984?
Make the answer very short. 1.02. What is the ratio of the Mineral Rent(as % of GDP) in Other Minerals in 1983 to that in 1984?
Give a very brief answer. 1.84. What is the ratio of the Mineral Rent(as % of GDP) in Coal in 1983 to that in 1985?
Provide a short and direct response. 1.27. What is the ratio of the Mineral Rent(as % of GDP) in Natural Gas in 1983 to that in 1985?
Provide a succinct answer. 1.09. What is the ratio of the Mineral Rent(as % of GDP) of Oil in 1983 to that in 1985?
Provide a succinct answer. 1.09. What is the ratio of the Mineral Rent(as % of GDP) of Other Minerals in 1983 to that in 1985?
Give a very brief answer. 28.34. What is the ratio of the Mineral Rent(as % of GDP) in Coal in 1983 to that in 2004?
Provide a short and direct response. 8.04. What is the ratio of the Mineral Rent(as % of GDP) in Natural Gas in 1983 to that in 2004?
Offer a terse response. 2.68. What is the ratio of the Mineral Rent(as % of GDP) in Oil in 1983 to that in 2004?
Offer a very short reply. 1.35. What is the ratio of the Mineral Rent(as % of GDP) of Other Minerals in 1983 to that in 2004?
Your answer should be compact. 5.6. What is the ratio of the Mineral Rent(as % of GDP) of Coal in 1983 to that in 2005?
Provide a short and direct response. 35.2. What is the ratio of the Mineral Rent(as % of GDP) of Natural Gas in 1983 to that in 2005?
Provide a succinct answer. 1.85. What is the ratio of the Mineral Rent(as % of GDP) in Oil in 1983 to that in 2005?
Your answer should be very brief. 0.84. What is the ratio of the Mineral Rent(as % of GDP) in Other Minerals in 1983 to that in 2005?
Your answer should be very brief. 5.43. What is the ratio of the Mineral Rent(as % of GDP) of Coal in 1983 to that in 2006?
Offer a terse response. 104.16. What is the ratio of the Mineral Rent(as % of GDP) of Natural Gas in 1983 to that in 2006?
Offer a terse response. 2.22. What is the ratio of the Mineral Rent(as % of GDP) of Oil in 1983 to that in 2006?
Your response must be concise. 0.77. What is the ratio of the Mineral Rent(as % of GDP) in Other Minerals in 1983 to that in 2006?
Offer a terse response. 2.28. What is the ratio of the Mineral Rent(as % of GDP) of Coal in 1983 to that in 2007?
Your answer should be compact. 4.84. What is the ratio of the Mineral Rent(as % of GDP) in Natural Gas in 1983 to that in 2007?
Provide a succinct answer. 2.88. What is the ratio of the Mineral Rent(as % of GDP) in Oil in 1983 to that in 2007?
Ensure brevity in your answer.  0.78. What is the ratio of the Mineral Rent(as % of GDP) in Other Minerals in 1983 to that in 2007?
Offer a very short reply. 0.91. What is the ratio of the Mineral Rent(as % of GDP) in Coal in 1984 to that in 1985?
Provide a short and direct response. 0.29. What is the ratio of the Mineral Rent(as % of GDP) of Natural Gas in 1984 to that in 1985?
Provide a short and direct response. 1.11. What is the ratio of the Mineral Rent(as % of GDP) of Oil in 1984 to that in 1985?
Give a very brief answer. 1.07. What is the ratio of the Mineral Rent(as % of GDP) in Other Minerals in 1984 to that in 1985?
Make the answer very short. 15.38. What is the ratio of the Mineral Rent(as % of GDP) of Coal in 1984 to that in 2004?
Your answer should be compact. 1.82. What is the ratio of the Mineral Rent(as % of GDP) of Natural Gas in 1984 to that in 2004?
Make the answer very short. 2.75. What is the ratio of the Mineral Rent(as % of GDP) of Oil in 1984 to that in 2004?
Your answer should be very brief. 1.32. What is the ratio of the Mineral Rent(as % of GDP) of Other Minerals in 1984 to that in 2004?
Your answer should be very brief. 3.04. What is the ratio of the Mineral Rent(as % of GDP) in Coal in 1984 to that in 2005?
Make the answer very short. 7.99. What is the ratio of the Mineral Rent(as % of GDP) in Natural Gas in 1984 to that in 2005?
Offer a very short reply. 1.89. What is the ratio of the Mineral Rent(as % of GDP) of Oil in 1984 to that in 2005?
Provide a succinct answer. 0.83. What is the ratio of the Mineral Rent(as % of GDP) of Other Minerals in 1984 to that in 2005?
Your response must be concise. 2.95. What is the ratio of the Mineral Rent(as % of GDP) in Coal in 1984 to that in 2006?
Provide a short and direct response. 23.63. What is the ratio of the Mineral Rent(as % of GDP) of Natural Gas in 1984 to that in 2006?
Provide a succinct answer. 2.27. What is the ratio of the Mineral Rent(as % of GDP) of Oil in 1984 to that in 2006?
Your answer should be very brief. 0.76. What is the ratio of the Mineral Rent(as % of GDP) of Other Minerals in 1984 to that in 2006?
Ensure brevity in your answer.  1.24. What is the ratio of the Mineral Rent(as % of GDP) of Coal in 1984 to that in 2007?
Your response must be concise. 1.1. What is the ratio of the Mineral Rent(as % of GDP) of Natural Gas in 1984 to that in 2007?
Your response must be concise. 2.95. What is the ratio of the Mineral Rent(as % of GDP) of Oil in 1984 to that in 2007?
Make the answer very short. 0.77. What is the ratio of the Mineral Rent(as % of GDP) of Other Minerals in 1984 to that in 2007?
Ensure brevity in your answer.  0.49. What is the ratio of the Mineral Rent(as % of GDP) in Coal in 1985 to that in 2004?
Your response must be concise. 6.31. What is the ratio of the Mineral Rent(as % of GDP) of Natural Gas in 1985 to that in 2004?
Provide a short and direct response. 2.47. What is the ratio of the Mineral Rent(as % of GDP) of Oil in 1985 to that in 2004?
Provide a succinct answer. 1.23. What is the ratio of the Mineral Rent(as % of GDP) of Other Minerals in 1985 to that in 2004?
Ensure brevity in your answer.  0.2. What is the ratio of the Mineral Rent(as % of GDP) of Coal in 1985 to that in 2005?
Give a very brief answer. 27.63. What is the ratio of the Mineral Rent(as % of GDP) of Natural Gas in 1985 to that in 2005?
Offer a very short reply. 1.7. What is the ratio of the Mineral Rent(as % of GDP) in Oil in 1985 to that in 2005?
Keep it short and to the point. 0.77. What is the ratio of the Mineral Rent(as % of GDP) in Other Minerals in 1985 to that in 2005?
Offer a very short reply. 0.19. What is the ratio of the Mineral Rent(as % of GDP) of Coal in 1985 to that in 2006?
Give a very brief answer. 81.77. What is the ratio of the Mineral Rent(as % of GDP) in Natural Gas in 1985 to that in 2006?
Make the answer very short. 2.04. What is the ratio of the Mineral Rent(as % of GDP) of Oil in 1985 to that in 2006?
Provide a succinct answer. 0.71. What is the ratio of the Mineral Rent(as % of GDP) of Other Minerals in 1985 to that in 2006?
Your answer should be very brief. 0.08. What is the ratio of the Mineral Rent(as % of GDP) of Coal in 1985 to that in 2007?
Your answer should be compact. 3.8. What is the ratio of the Mineral Rent(as % of GDP) of Natural Gas in 1985 to that in 2007?
Make the answer very short. 2.65. What is the ratio of the Mineral Rent(as % of GDP) in Oil in 1985 to that in 2007?
Your response must be concise. 0.72. What is the ratio of the Mineral Rent(as % of GDP) of Other Minerals in 1985 to that in 2007?
Your answer should be compact. 0.03. What is the ratio of the Mineral Rent(as % of GDP) of Coal in 2004 to that in 2005?
Provide a short and direct response. 4.38. What is the ratio of the Mineral Rent(as % of GDP) in Natural Gas in 2004 to that in 2005?
Offer a very short reply. 0.69. What is the ratio of the Mineral Rent(as % of GDP) in Oil in 2004 to that in 2005?
Your answer should be very brief. 0.62. What is the ratio of the Mineral Rent(as % of GDP) of Other Minerals in 2004 to that in 2005?
Your answer should be compact. 0.97. What is the ratio of the Mineral Rent(as % of GDP) of Coal in 2004 to that in 2006?
Make the answer very short. 12.96. What is the ratio of the Mineral Rent(as % of GDP) of Natural Gas in 2004 to that in 2006?
Your answer should be compact. 0.83. What is the ratio of the Mineral Rent(as % of GDP) of Oil in 2004 to that in 2006?
Offer a terse response. 0.57. What is the ratio of the Mineral Rent(as % of GDP) of Other Minerals in 2004 to that in 2006?
Offer a terse response. 0.41. What is the ratio of the Mineral Rent(as % of GDP) in Coal in 2004 to that in 2007?
Give a very brief answer. 0.6. What is the ratio of the Mineral Rent(as % of GDP) of Natural Gas in 2004 to that in 2007?
Offer a terse response. 1.07. What is the ratio of the Mineral Rent(as % of GDP) in Oil in 2004 to that in 2007?
Offer a very short reply. 0.58. What is the ratio of the Mineral Rent(as % of GDP) of Other Minerals in 2004 to that in 2007?
Provide a short and direct response. 0.16. What is the ratio of the Mineral Rent(as % of GDP) in Coal in 2005 to that in 2006?
Offer a terse response. 2.96. What is the ratio of the Mineral Rent(as % of GDP) of Natural Gas in 2005 to that in 2006?
Provide a succinct answer. 1.2. What is the ratio of the Mineral Rent(as % of GDP) of Oil in 2005 to that in 2006?
Offer a very short reply. 0.92. What is the ratio of the Mineral Rent(as % of GDP) in Other Minerals in 2005 to that in 2006?
Ensure brevity in your answer.  0.42. What is the ratio of the Mineral Rent(as % of GDP) in Coal in 2005 to that in 2007?
Keep it short and to the point. 0.14. What is the ratio of the Mineral Rent(as % of GDP) in Natural Gas in 2005 to that in 2007?
Offer a terse response. 1.56. What is the ratio of the Mineral Rent(as % of GDP) in Oil in 2005 to that in 2007?
Offer a very short reply. 0.93. What is the ratio of the Mineral Rent(as % of GDP) in Other Minerals in 2005 to that in 2007?
Offer a terse response. 0.17. What is the ratio of the Mineral Rent(as % of GDP) of Coal in 2006 to that in 2007?
Your answer should be very brief. 0.05. What is the ratio of the Mineral Rent(as % of GDP) of Natural Gas in 2006 to that in 2007?
Offer a terse response. 1.3. What is the ratio of the Mineral Rent(as % of GDP) in Oil in 2006 to that in 2007?
Provide a short and direct response. 1.02. What is the ratio of the Mineral Rent(as % of GDP) in Other Minerals in 2006 to that in 2007?
Make the answer very short. 0.4. What is the difference between the highest and the second highest Mineral Rent(as % of GDP) of Natural Gas?
Make the answer very short. 0.01. What is the difference between the highest and the second highest Mineral Rent(as % of GDP) of Oil?
Make the answer very short. 0. What is the difference between the highest and the second highest Mineral Rent(as % of GDP) of Other Minerals?
Ensure brevity in your answer.  0. What is the difference between the highest and the lowest Mineral Rent(as % of GDP) in Coal?
Offer a very short reply. 0. What is the difference between the highest and the lowest Mineral Rent(as % of GDP) in Natural Gas?
Provide a succinct answer. 0.18. What is the difference between the highest and the lowest Mineral Rent(as % of GDP) of Oil?
Keep it short and to the point. 0.05. 